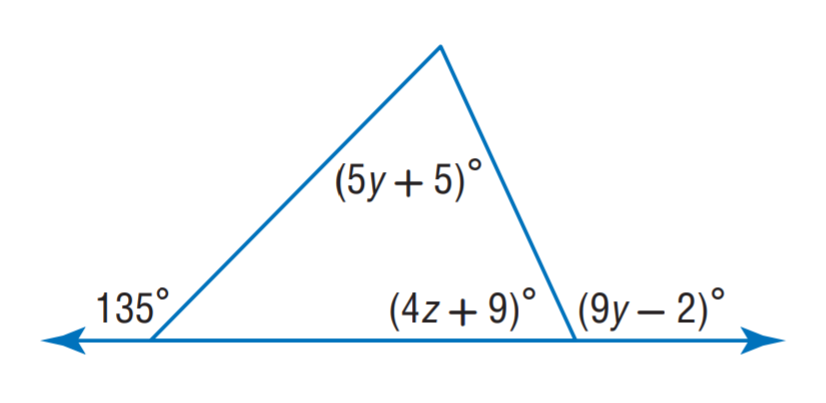Answer the mathemtical geometry problem and directly provide the correct option letter.
Question: Find z.
Choices: A: 12 B: 13 C: 14 D: 15 C 